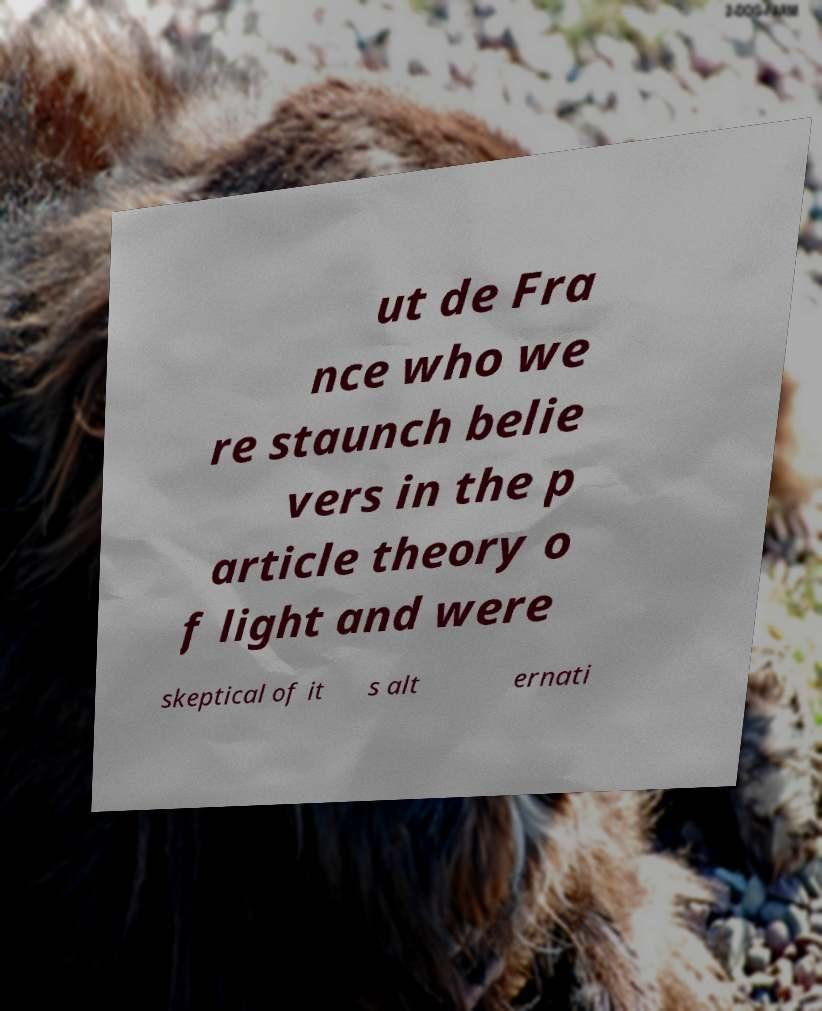Can you accurately transcribe the text from the provided image for me? ut de Fra nce who we re staunch belie vers in the p article theory o f light and were skeptical of it s alt ernati 